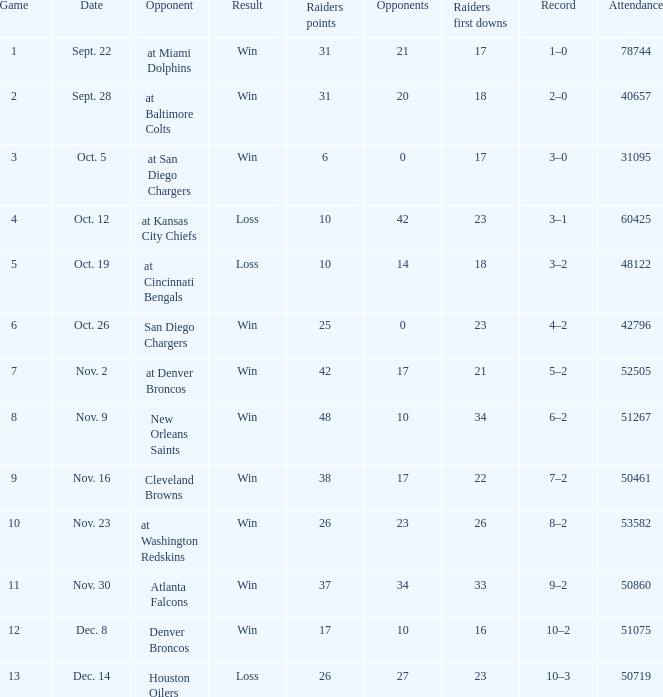For the 9th game, what is the number of unique first downs achieved by the raiders? 1.0. 